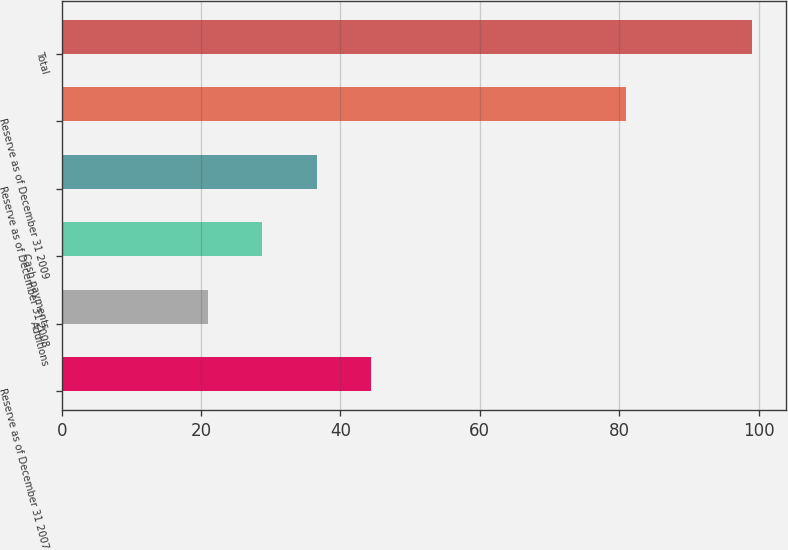Convert chart to OTSL. <chart><loc_0><loc_0><loc_500><loc_500><bar_chart><fcel>Reserve as of December 31 2007<fcel>Additions<fcel>Cash payments<fcel>Reserve as of December 31 2008<fcel>Reserve as of December 31 2009<fcel>Total<nl><fcel>44.4<fcel>21<fcel>28.8<fcel>36.6<fcel>81<fcel>99<nl></chart> 